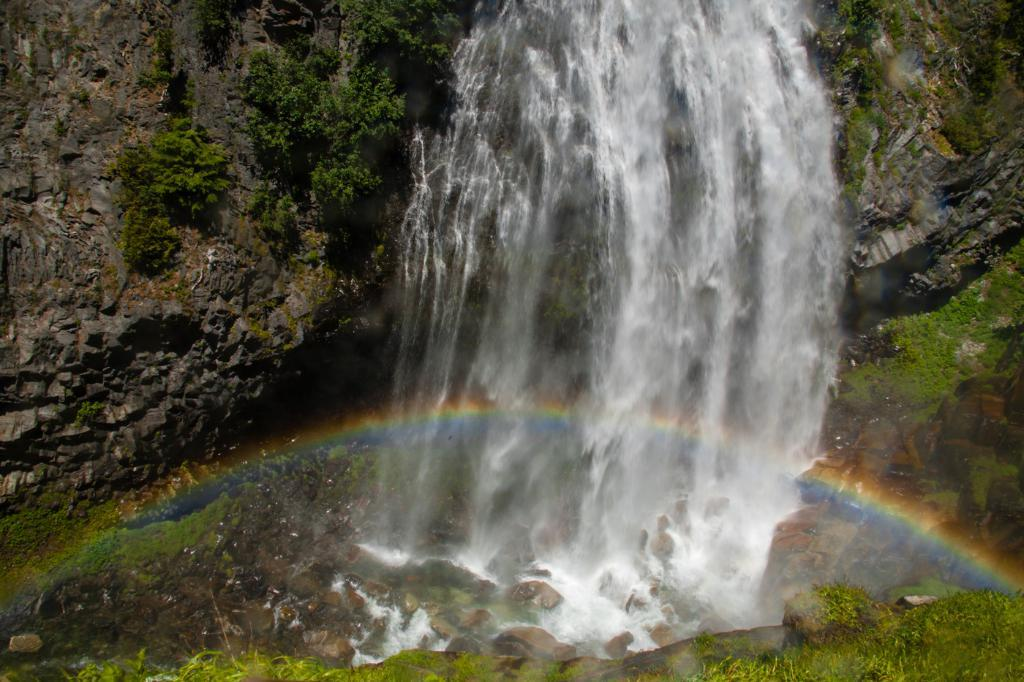What natural feature is the main subject of the image? There is a waterfall in the image. Where does the waterfall originate from? The waterfall is coming from a rock. What can be seen below the waterfall? There are rocks visible below the waterfall. What type of vegetation is present in the image? There is grass in the image. Who is the owner of the house in the image? There is no house present in the image, so it is not possible to determine the owner. 